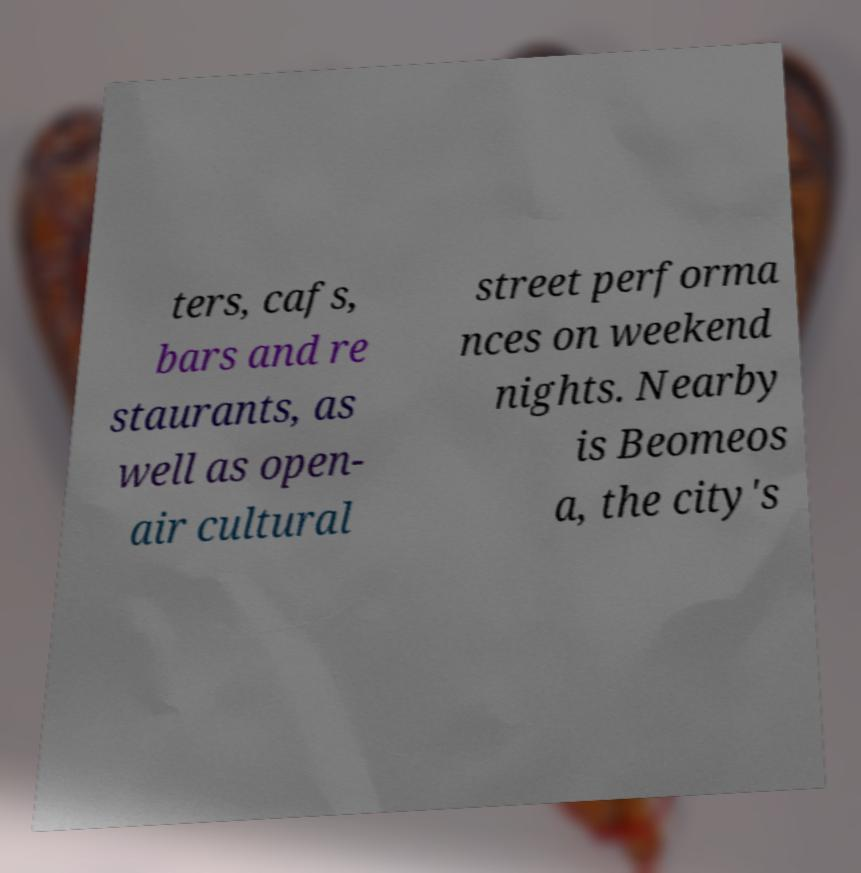For documentation purposes, I need the text within this image transcribed. Could you provide that? ters, cafs, bars and re staurants, as well as open- air cultural street performa nces on weekend nights. Nearby is Beomeos a, the city's 